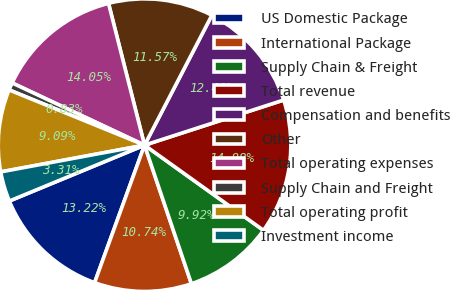<chart> <loc_0><loc_0><loc_500><loc_500><pie_chart><fcel>US Domestic Package<fcel>International Package<fcel>Supply Chain & Freight<fcel>Total revenue<fcel>Compensation and benefits<fcel>Other<fcel>Total operating expenses<fcel>Supply Chain and Freight<fcel>Total operating profit<fcel>Investment income<nl><fcel>13.22%<fcel>10.74%<fcel>9.92%<fcel>14.88%<fcel>12.4%<fcel>11.57%<fcel>14.05%<fcel>0.83%<fcel>9.09%<fcel>3.31%<nl></chart> 